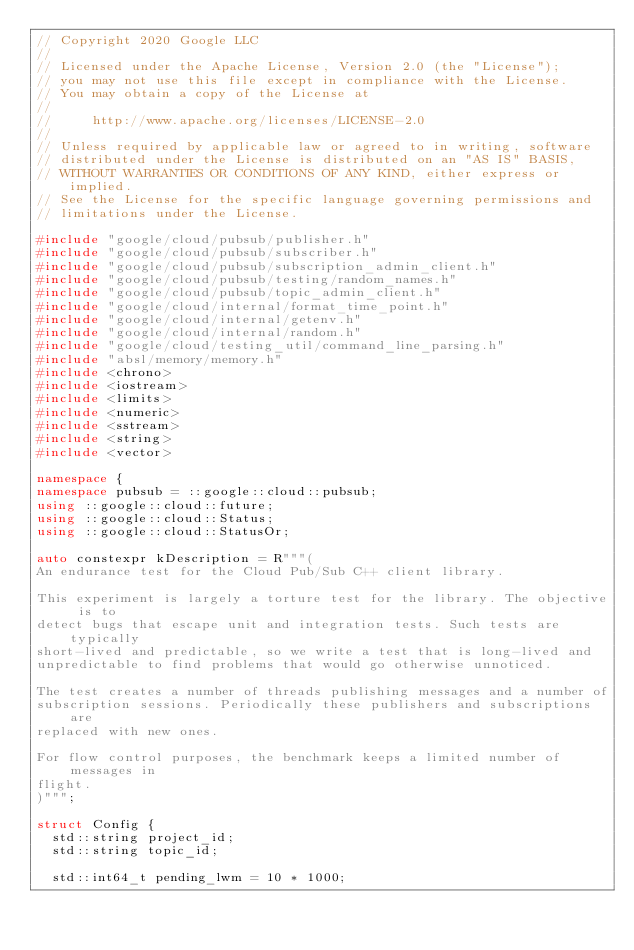Convert code to text. <code><loc_0><loc_0><loc_500><loc_500><_C++_>// Copyright 2020 Google LLC
//
// Licensed under the Apache License, Version 2.0 (the "License");
// you may not use this file except in compliance with the License.
// You may obtain a copy of the License at
//
//     http://www.apache.org/licenses/LICENSE-2.0
//
// Unless required by applicable law or agreed to in writing, software
// distributed under the License is distributed on an "AS IS" BASIS,
// WITHOUT WARRANTIES OR CONDITIONS OF ANY KIND, either express or implied.
// See the License for the specific language governing permissions and
// limitations under the License.

#include "google/cloud/pubsub/publisher.h"
#include "google/cloud/pubsub/subscriber.h"
#include "google/cloud/pubsub/subscription_admin_client.h"
#include "google/cloud/pubsub/testing/random_names.h"
#include "google/cloud/pubsub/topic_admin_client.h"
#include "google/cloud/internal/format_time_point.h"
#include "google/cloud/internal/getenv.h"
#include "google/cloud/internal/random.h"
#include "google/cloud/testing_util/command_line_parsing.h"
#include "absl/memory/memory.h"
#include <chrono>
#include <iostream>
#include <limits>
#include <numeric>
#include <sstream>
#include <string>
#include <vector>

namespace {
namespace pubsub = ::google::cloud::pubsub;
using ::google::cloud::future;
using ::google::cloud::Status;
using ::google::cloud::StatusOr;

auto constexpr kDescription = R"""(
An endurance test for the Cloud Pub/Sub C++ client library.

This experiment is largely a torture test for the library. The objective is to
detect bugs that escape unit and integration tests. Such tests are typically
short-lived and predictable, so we write a test that is long-lived and
unpredictable to find problems that would go otherwise unnoticed.

The test creates a number of threads publishing messages and a number of
subscription sessions. Periodically these publishers and subscriptions are
replaced with new ones.

For flow control purposes, the benchmark keeps a limited number of messages in
flight.
)""";

struct Config {
  std::string project_id;
  std::string topic_id;

  std::int64_t pending_lwm = 10 * 1000;</code> 